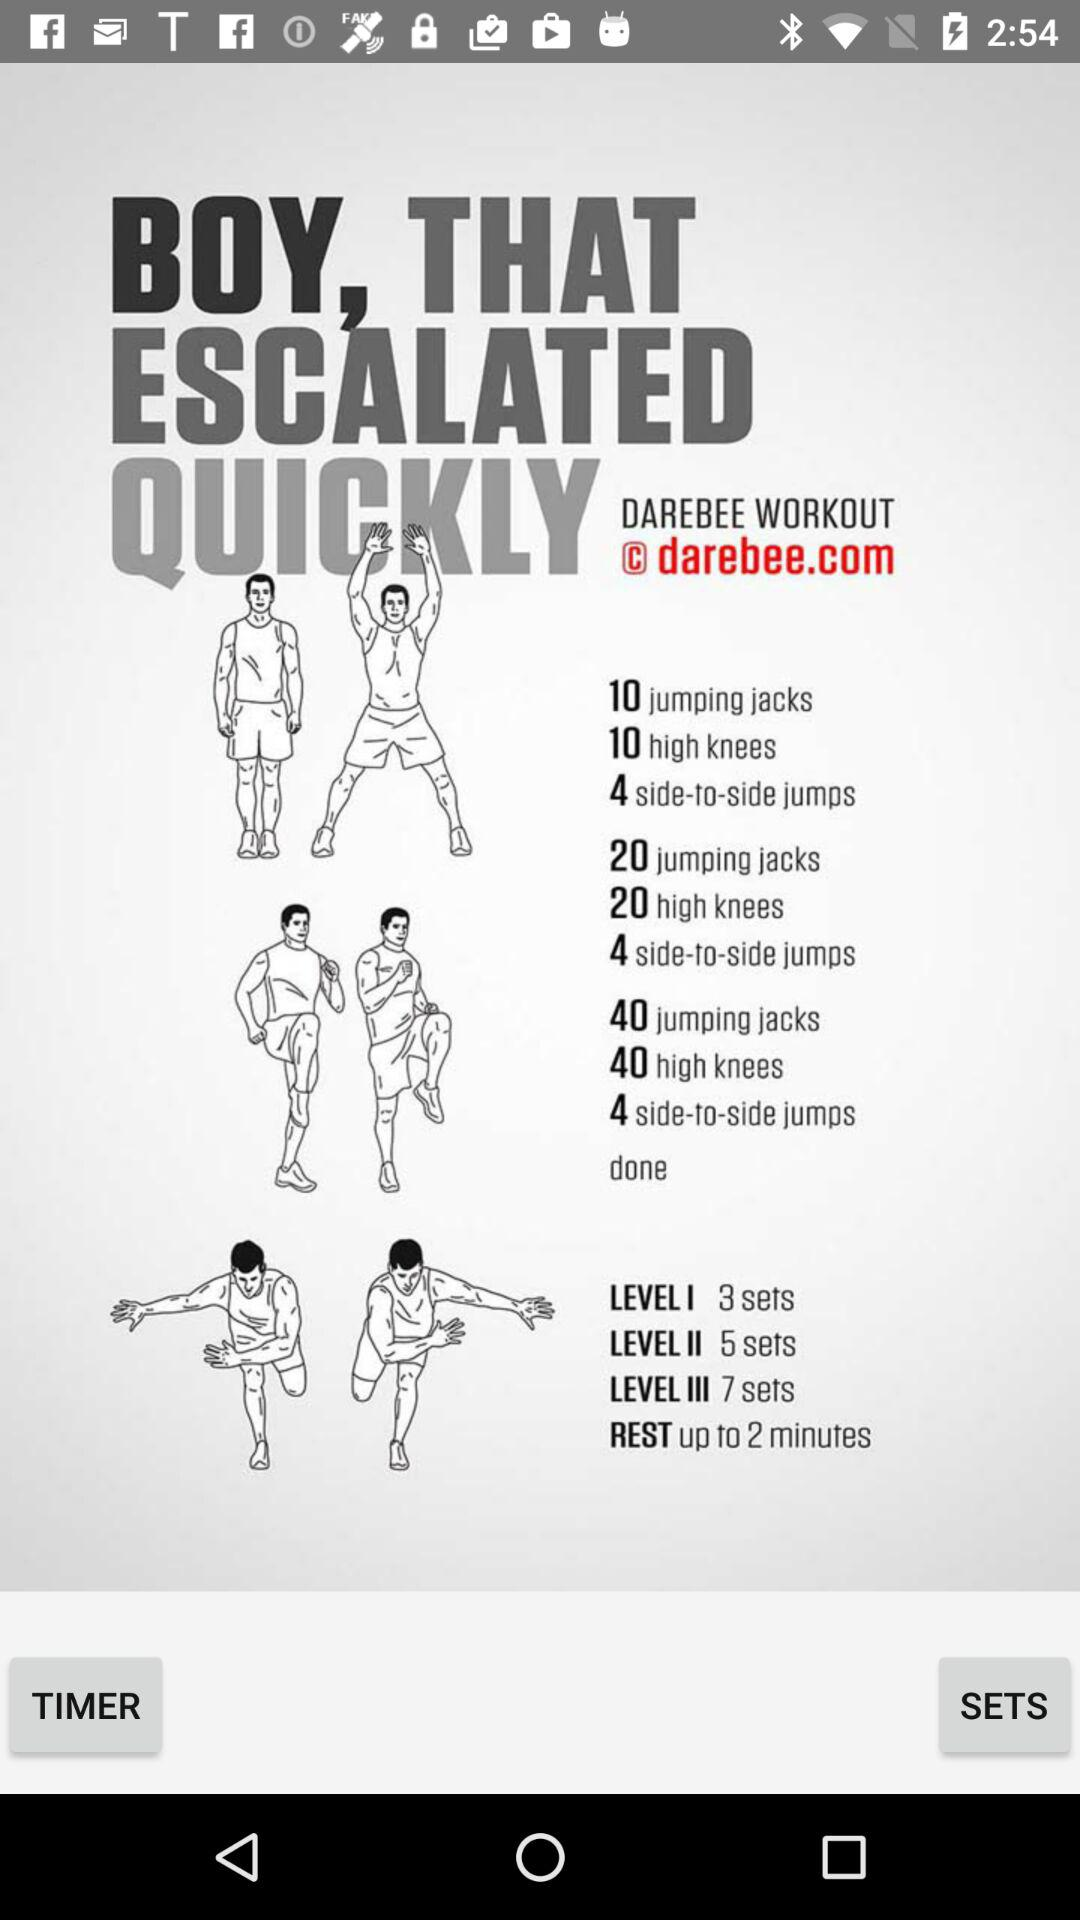What is the number of sets in level 3? The number of sets in level 3 is 7. 